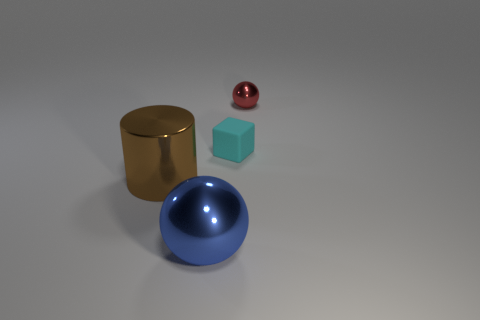Add 3 blue metallic objects. How many objects exist? 7 Subtract all blocks. How many objects are left? 3 Subtract all small cyan things. Subtract all metallic spheres. How many objects are left? 1 Add 4 cyan rubber cubes. How many cyan rubber cubes are left? 5 Add 4 yellow things. How many yellow things exist? 4 Subtract 1 cyan cubes. How many objects are left? 3 